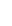<formula> <loc_0><loc_0><loc_500><loc_500>\begin{array} { r l } \end{array}</formula> 